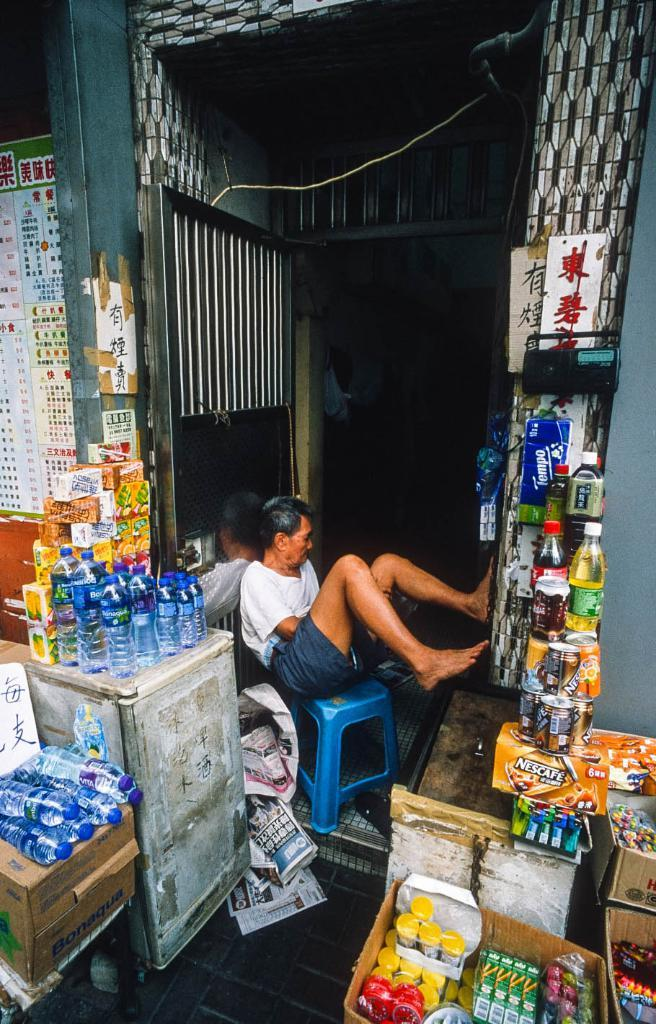<image>
Create a compact narrative representing the image presented. Man sitting in a store front that is selling an item called NESCAFE. 